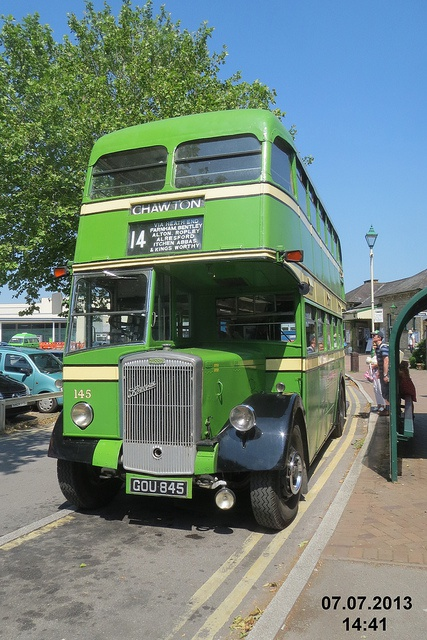Describe the objects in this image and their specific colors. I can see bus in gray, black, darkgray, and green tones, car in gray, teal, black, and blue tones, car in gray, black, teal, and darkgray tones, people in gray, black, and darkgray tones, and bench in gray, black, and teal tones in this image. 